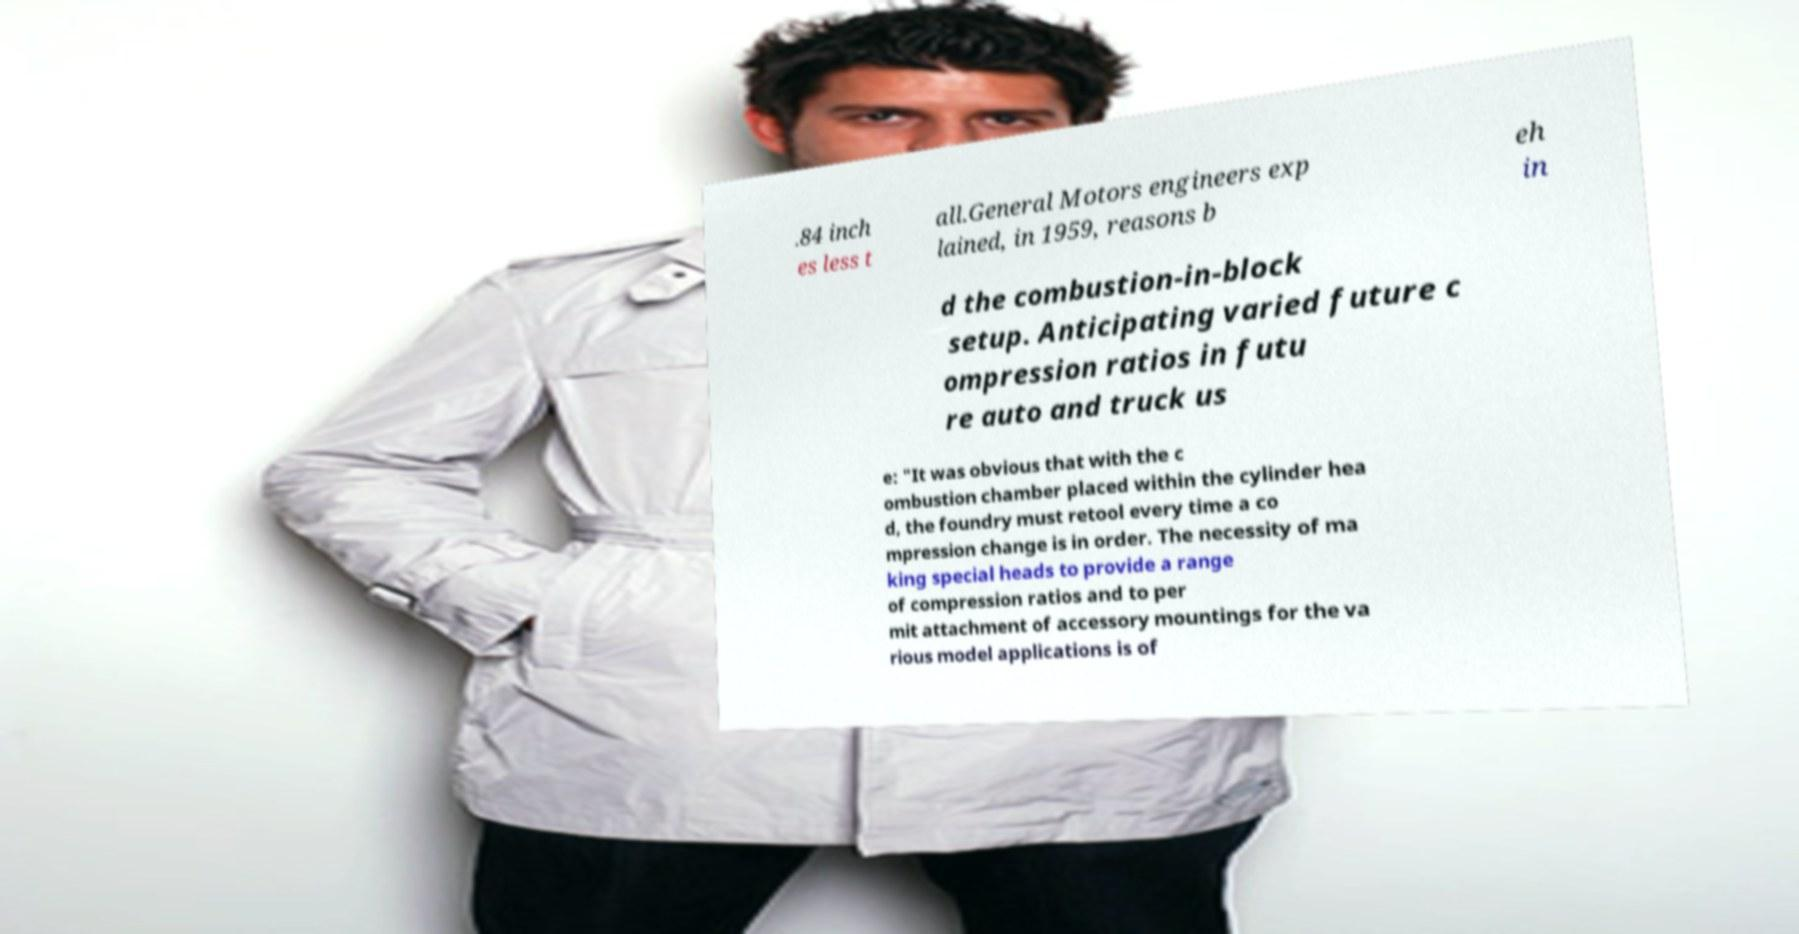Please read and relay the text visible in this image. What does it say? .84 inch es less t all.General Motors engineers exp lained, in 1959, reasons b eh in d the combustion-in-block setup. Anticipating varied future c ompression ratios in futu re auto and truck us e: "It was obvious that with the c ombustion chamber placed within the cylinder hea d, the foundry must retool every time a co mpression change is in order. The necessity of ma king special heads to provide a range of compression ratios and to per mit attachment of accessory mountings for the va rious model applications is of 